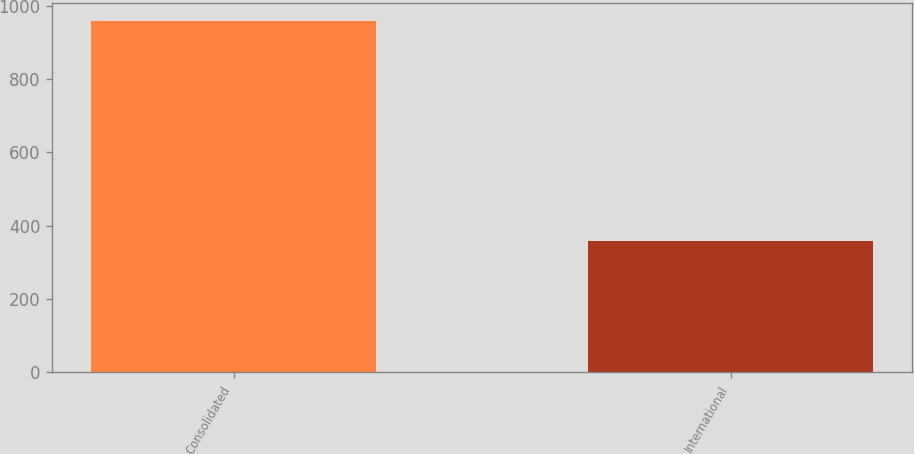Convert chart. <chart><loc_0><loc_0><loc_500><loc_500><bar_chart><fcel>Consolidated<fcel>International<nl><fcel>960.2<fcel>359<nl></chart> 